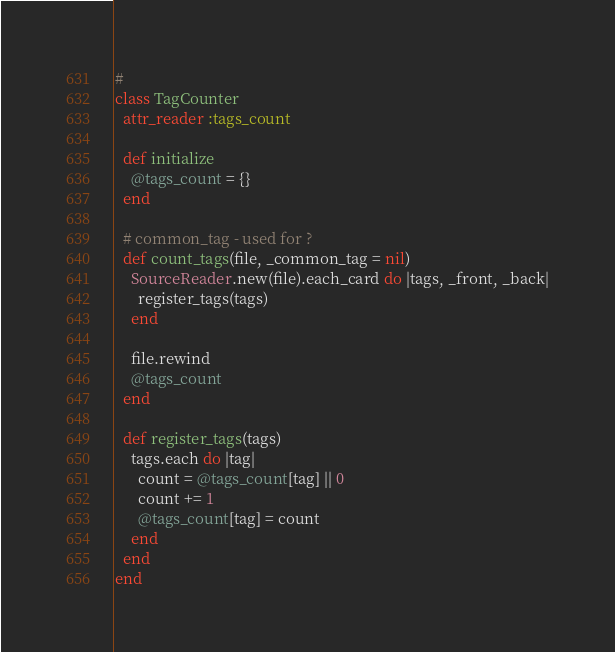<code> <loc_0><loc_0><loc_500><loc_500><_Ruby_>#
class TagCounter
  attr_reader :tags_count

  def initialize
    @tags_count = {}
  end

  # common_tag - used for ?
  def count_tags(file, _common_tag = nil)
    SourceReader.new(file).each_card do |tags, _front, _back|
      register_tags(tags)
    end

    file.rewind
    @tags_count
  end

  def register_tags(tags)
    tags.each do |tag|
      count = @tags_count[tag] || 0
      count += 1
      @tags_count[tag] = count
    end
  end
end
</code> 